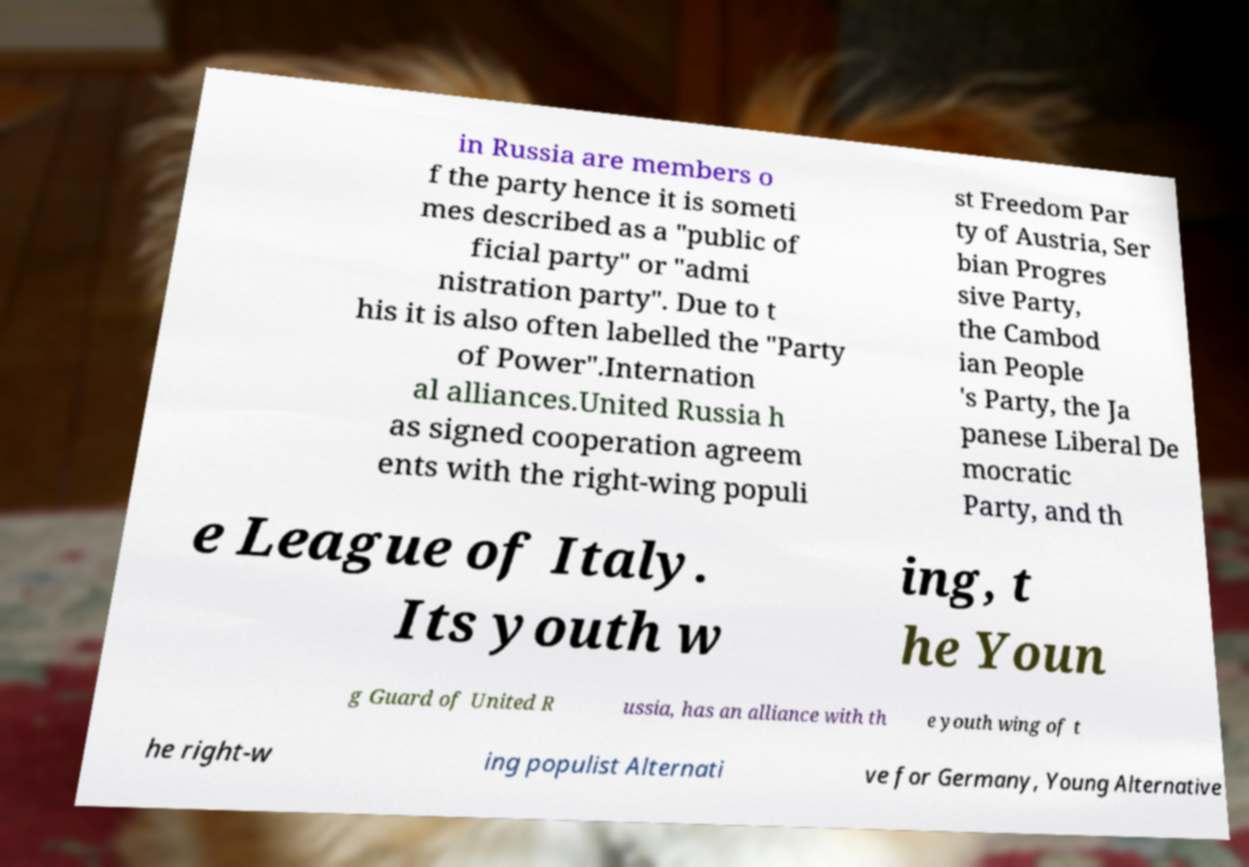Could you assist in decoding the text presented in this image and type it out clearly? in Russia are members o f the party hence it is someti mes described as a "public of ficial party" or "admi nistration party". Due to t his it is also often labelled the "Party of Power".Internation al alliances.United Russia h as signed cooperation agreem ents with the right-wing populi st Freedom Par ty of Austria, Ser bian Progres sive Party, the Cambod ian People 's Party, the Ja panese Liberal De mocratic Party, and th e League of Italy. Its youth w ing, t he Youn g Guard of United R ussia, has an alliance with th e youth wing of t he right-w ing populist Alternati ve for Germany, Young Alternative 